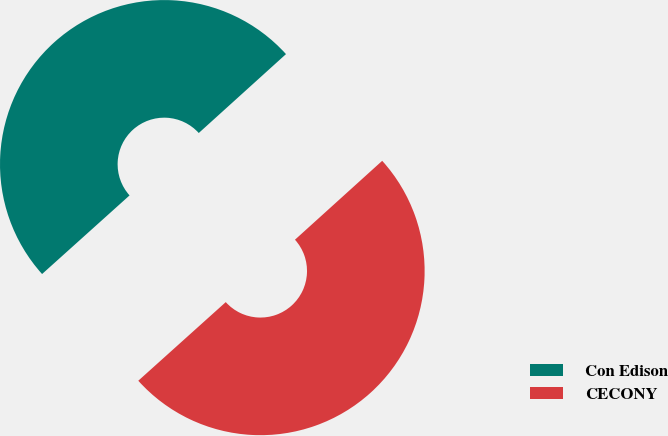Convert chart. <chart><loc_0><loc_0><loc_500><loc_500><pie_chart><fcel>Con Edison<fcel>CECONY<nl><fcel>49.95%<fcel>50.05%<nl></chart> 